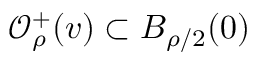<formula> <loc_0><loc_0><loc_500><loc_500>\mathcal { O } _ { \rho } ^ { + } ( v ) \subset B _ { \rho / 2 } ( 0 )</formula> 